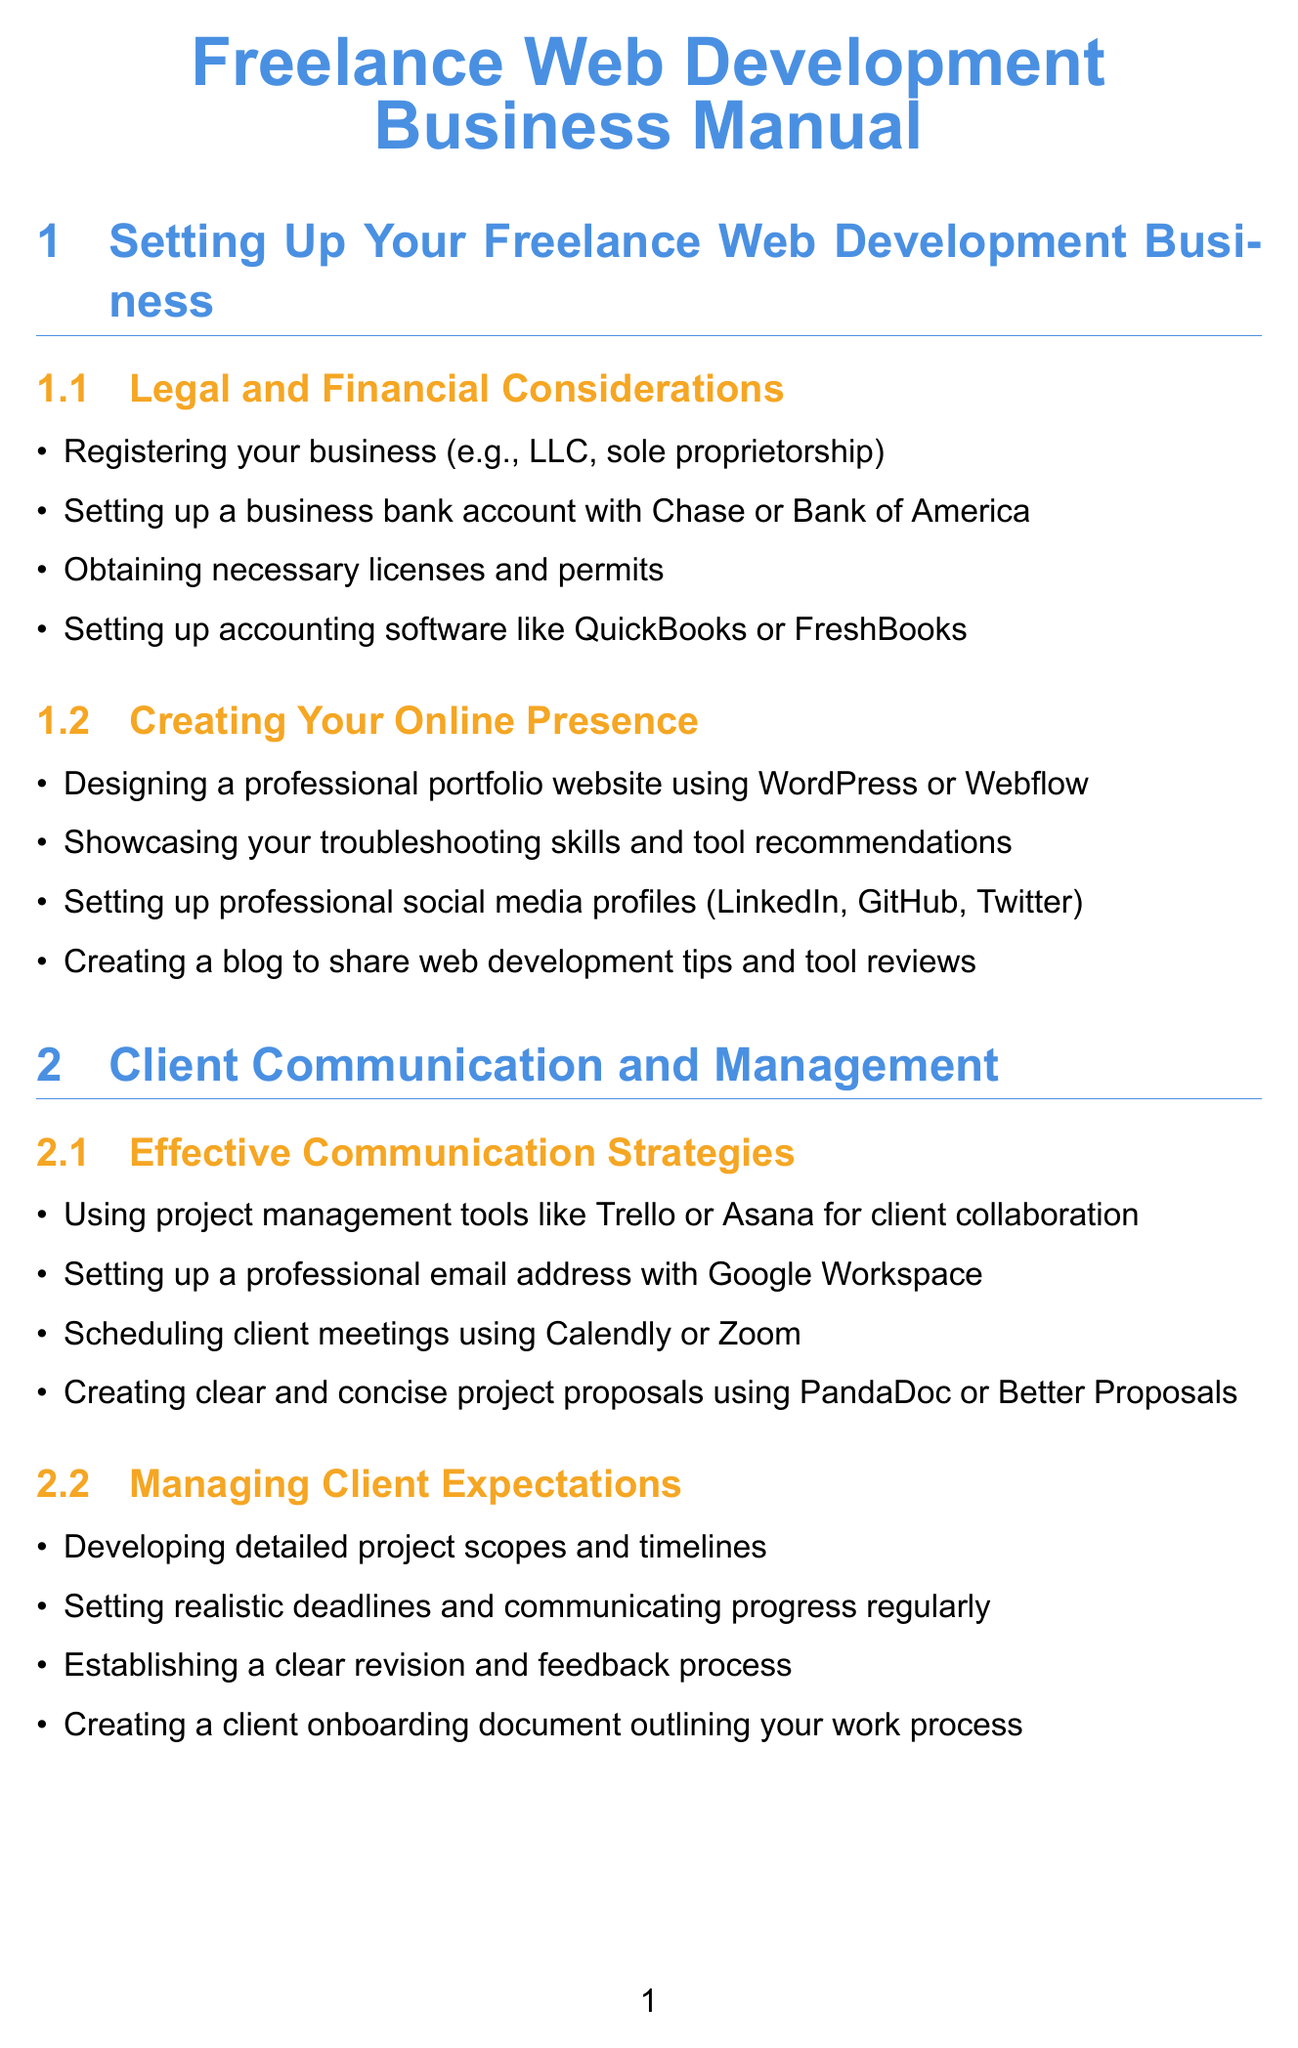what type of business registration is mentioned? The document lists various types of business registrations, specifically LLC and sole proprietorship as examples.
Answer: LLC, sole proprietorship which accounting software is recommended? The manual suggests specific accounting software options to set up for managing finances.
Answer: QuickBooks, FreshBooks what is a recommended tool for client meetings? The document provides options for scheduling meetings with clients, naming specific tools.
Answer: Calendly, Zoom what should be implemented to track billable hours? The document outlines specific tools for tracking work hours for billing purposes.
Answer: RescueTime, Toggl name one approach to managing client expectations. The manual emphasizes the importance of certain practices in maintaining healthy client relationships.
Answer: Developing detailed project scopes and timelines what is one way to expand service offerings? The document suggests learning new technologies as a means to expand the business services provided.
Answer: Learning new programming languages and frameworks what is a common invoicing software mentioned? The manual lists specific software tools to use for invoicing clients.
Answer: Wave, Invoice Ninja which platforms should be considered for creating a portfolio website? The document includes recommendations for platforms suitable for showcasing work to potential clients.
Answer: WordPress, Webflow what type of testing tools are mentioned for quality assurance? The manual lists specific tools that aid in testing the quality and functionality of developed websites.
Answer: BrowserStack, Responsinator 